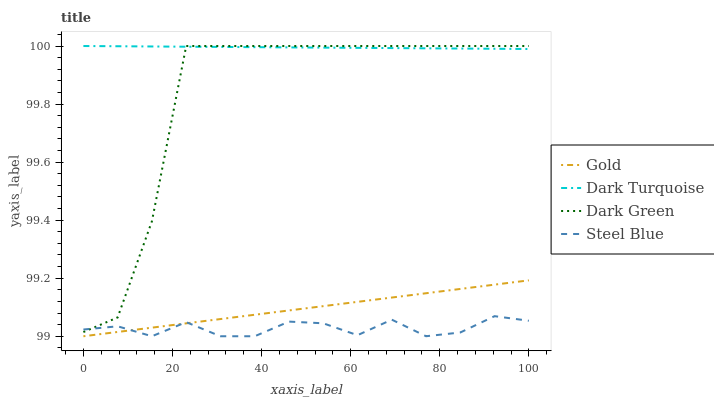Does Steel Blue have the minimum area under the curve?
Answer yes or no. Yes. Does Dark Turquoise have the maximum area under the curve?
Answer yes or no. Yes. Does Gold have the minimum area under the curve?
Answer yes or no. No. Does Gold have the maximum area under the curve?
Answer yes or no. No. Is Dark Turquoise the smoothest?
Answer yes or no. Yes. Is Dark Green the roughest?
Answer yes or no. Yes. Is Steel Blue the smoothest?
Answer yes or no. No. Is Steel Blue the roughest?
Answer yes or no. No. Does Steel Blue have the lowest value?
Answer yes or no. Yes. Does Dark Green have the lowest value?
Answer yes or no. No. Does Dark Green have the highest value?
Answer yes or no. Yes. Does Gold have the highest value?
Answer yes or no. No. Is Steel Blue less than Dark Turquoise?
Answer yes or no. Yes. Is Dark Green greater than Gold?
Answer yes or no. Yes. Does Dark Green intersect Dark Turquoise?
Answer yes or no. Yes. Is Dark Green less than Dark Turquoise?
Answer yes or no. No. Is Dark Green greater than Dark Turquoise?
Answer yes or no. No. Does Steel Blue intersect Dark Turquoise?
Answer yes or no. No. 